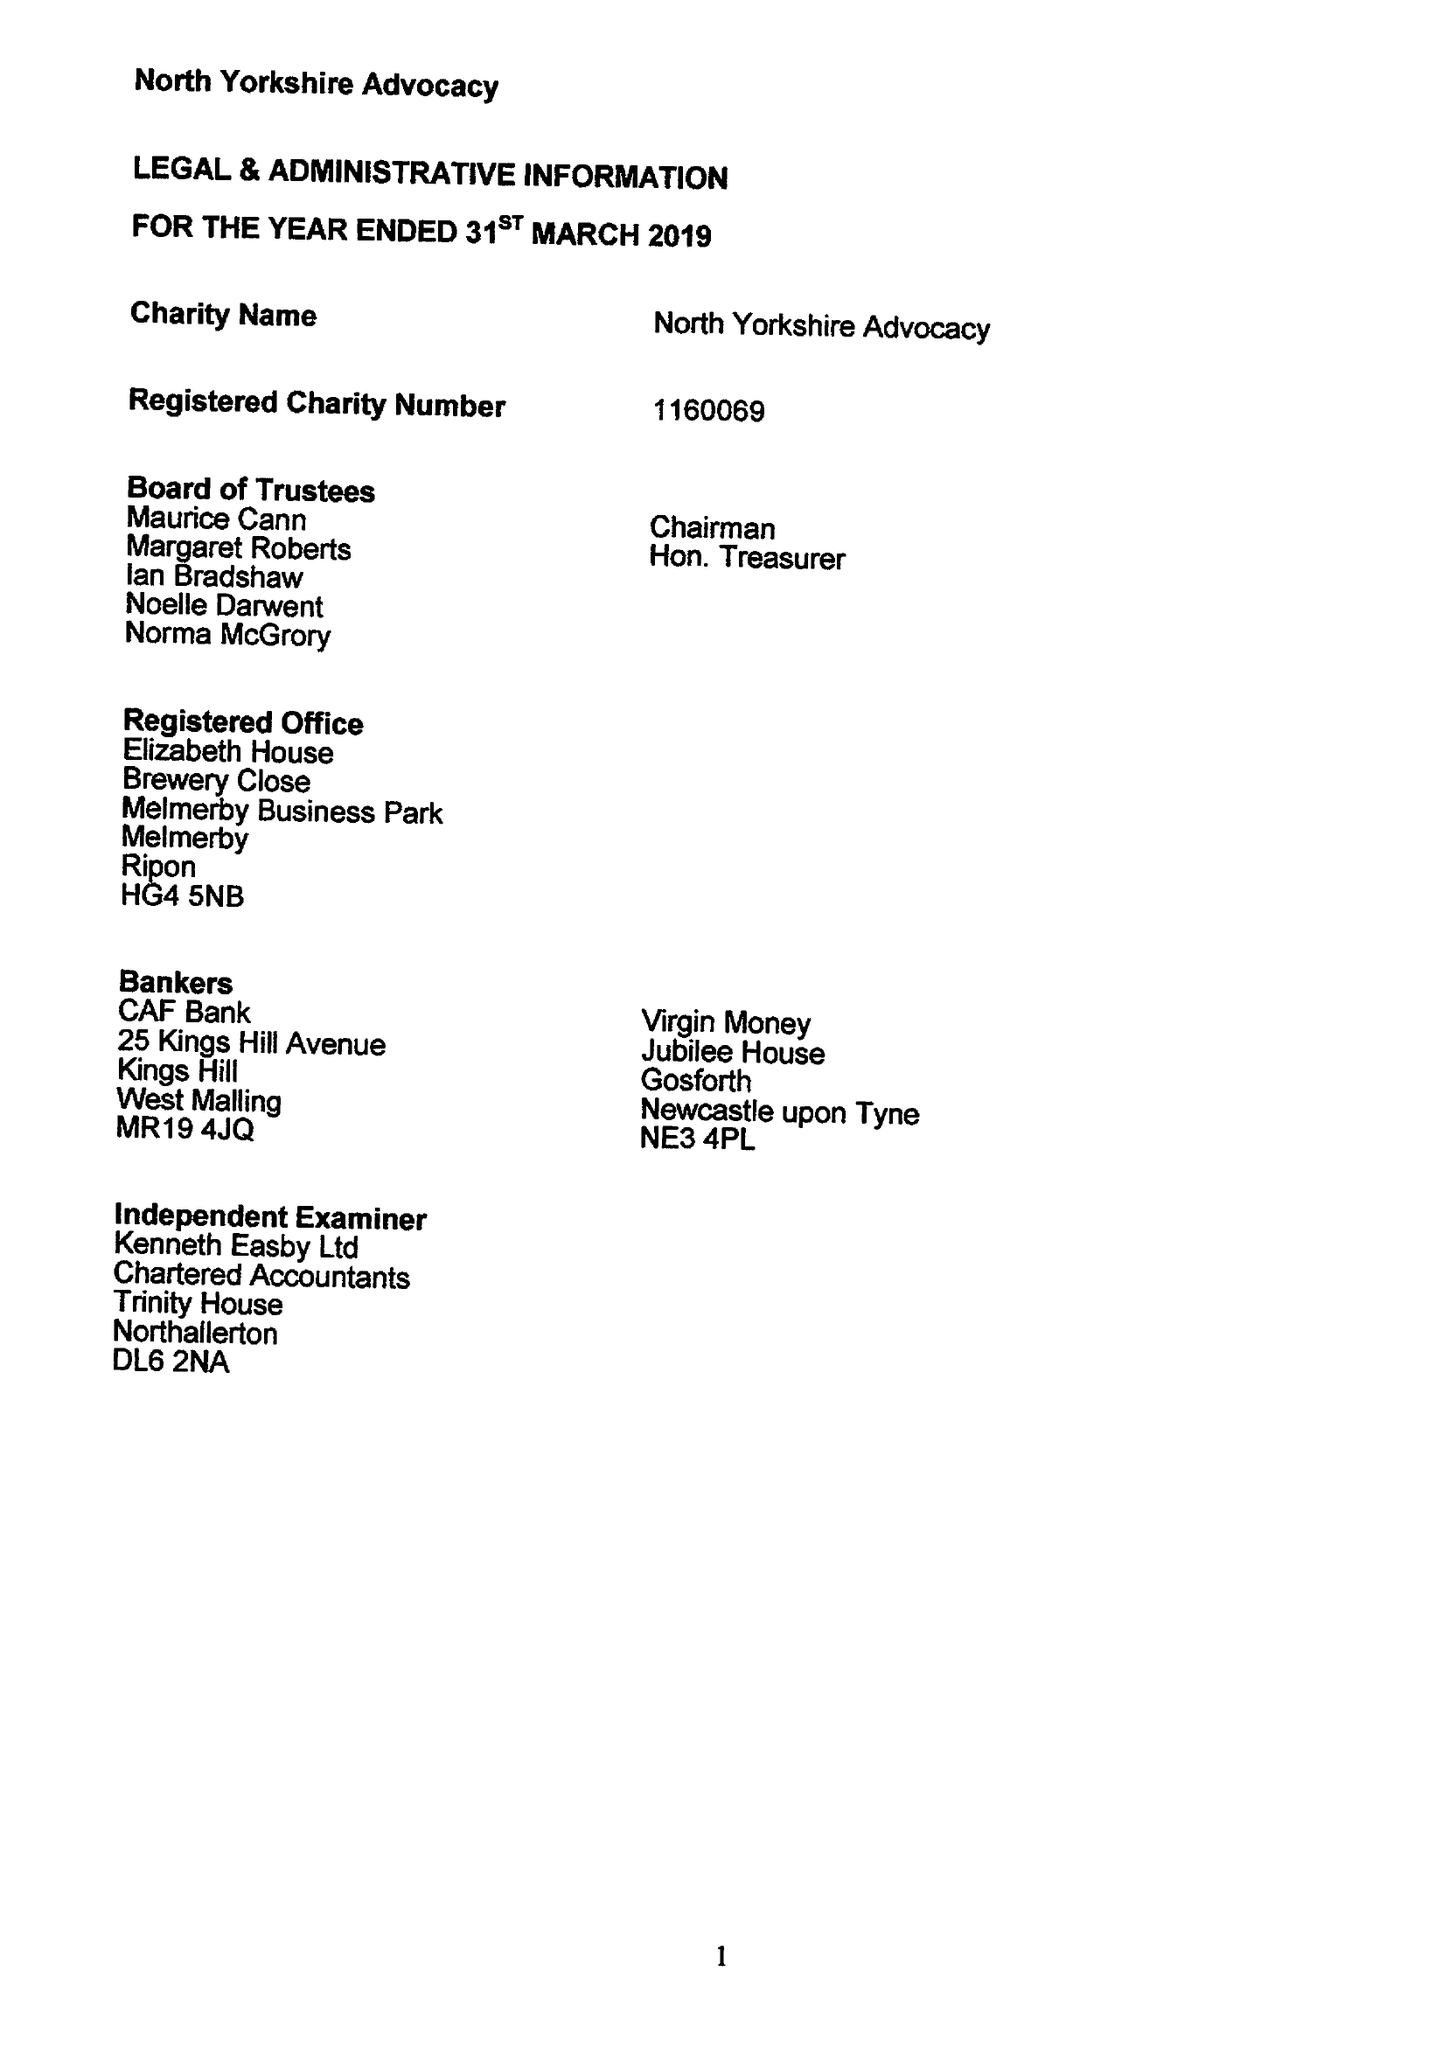What is the value for the address__street_line?
Answer the question using a single word or phrase. None 